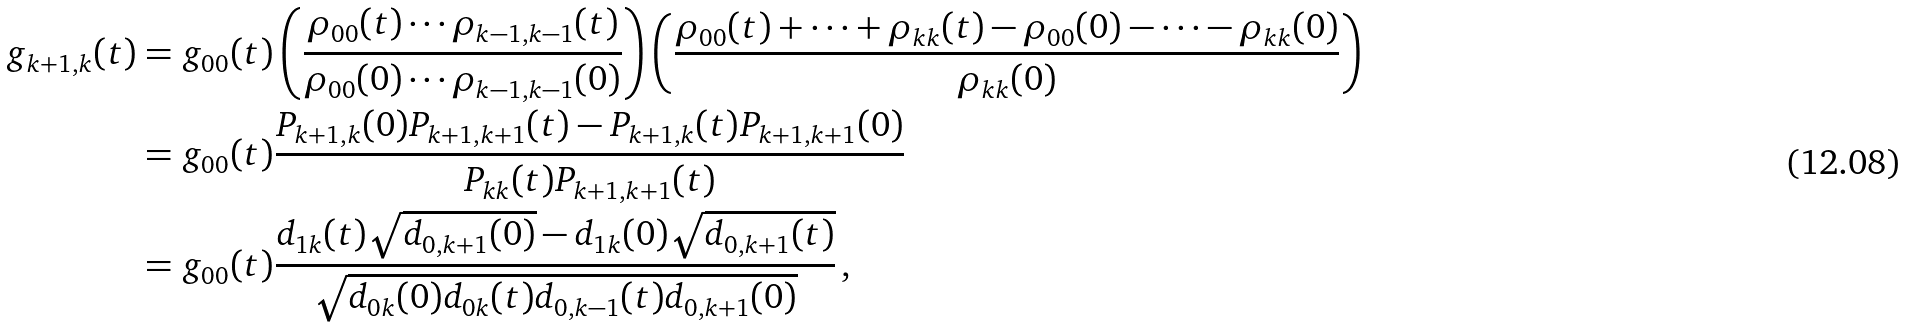<formula> <loc_0><loc_0><loc_500><loc_500>g _ { k + 1 , k } ( t ) & = g _ { 0 0 } ( t ) \left ( \frac { \rho _ { 0 0 } ( t ) \cdots \rho _ { k - 1 , k - 1 } ( t ) } { \rho _ { 0 0 } ( 0 ) \cdots \rho _ { k - 1 , k - 1 } ( 0 ) } \right ) \left ( \frac { \rho _ { 0 0 } ( t ) + \dots + \rho _ { k k } ( t ) - \rho _ { 0 0 } ( 0 ) - \cdots - \rho _ { k k } ( 0 ) } { \rho _ { k k } ( 0 ) } \right ) \\ & = g _ { 0 0 } ( t ) \frac { P _ { k + 1 , k } ( 0 ) P _ { k + 1 , k + 1 } ( t ) - P _ { k + 1 , k } ( t ) P _ { k + 1 , k + 1 } ( 0 ) } { P _ { k k } ( t ) P _ { k + 1 , k + 1 } ( t ) } \\ & = g _ { 0 0 } ( t ) \frac { d _ { 1 k } ( t ) \sqrt { d _ { 0 , k + 1 } ( 0 ) } - d _ { 1 k } ( 0 ) \sqrt { d _ { 0 , k + 1 } ( t ) } } { \sqrt { d _ { 0 k } ( 0 ) d _ { 0 k } ( t ) d _ { 0 , k - 1 } ( t ) d _ { 0 , k + 1 } ( 0 ) } } \, ,</formula> 